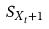Convert formula to latex. <formula><loc_0><loc_0><loc_500><loc_500>S _ { X _ { t } + 1 }</formula> 